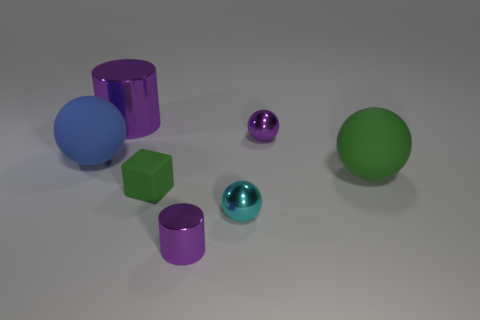Do the large shiny cylinder and the tiny cylinder have the same color?
Your answer should be very brief. Yes. What is the color of the rubber thing that is to the left of the purple shiny cylinder that is behind the tiny purple shiny cylinder?
Provide a short and direct response. Blue. There is a large metal thing; does it have the same shape as the green rubber object right of the cyan sphere?
Make the answer very short. No. How many metallic objects have the same size as the matte cube?
Keep it short and to the point. 3. There is a small cyan thing that is the same shape as the big green rubber object; what is it made of?
Provide a short and direct response. Metal. Do the metal cylinder on the right side of the big cylinder and the cylinder that is behind the large green sphere have the same color?
Offer a very short reply. Yes. What is the shape of the big thing that is in front of the blue object?
Your response must be concise. Sphere. What color is the rubber cube?
Provide a short and direct response. Green. There is a tiny green thing that is made of the same material as the large blue sphere; what shape is it?
Make the answer very short. Cube. There is a metal cylinder that is right of the green matte block; is its size the same as the purple shiny sphere?
Your answer should be very brief. Yes. 